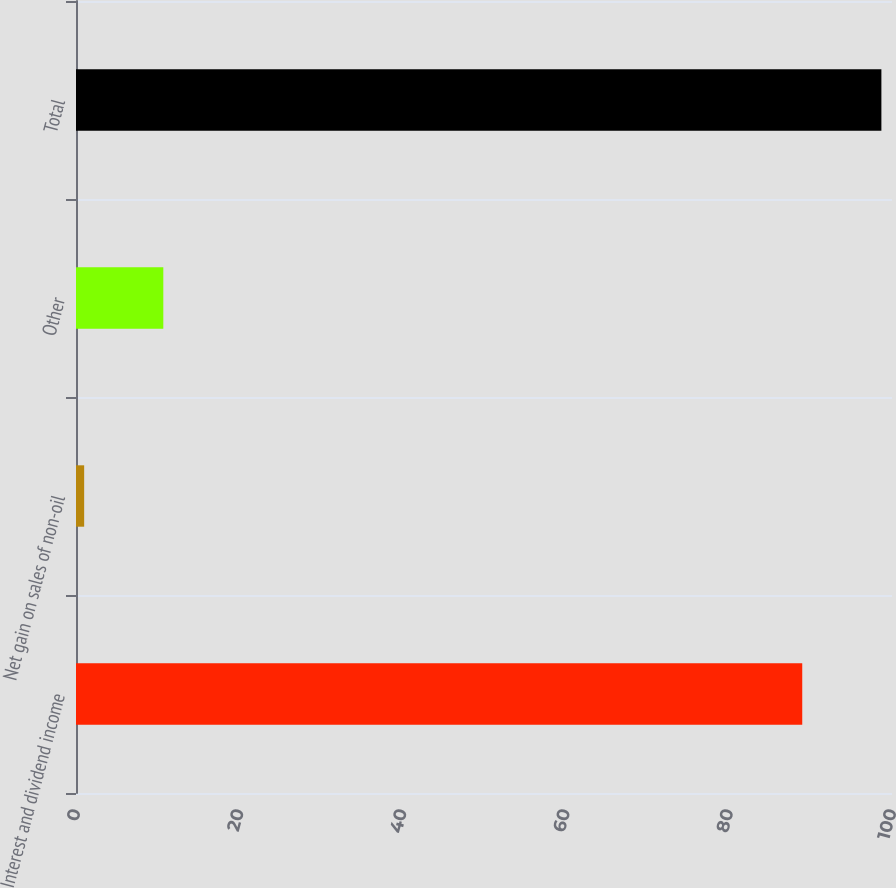<chart> <loc_0><loc_0><loc_500><loc_500><bar_chart><fcel>Interest and dividend income<fcel>Net gain on sales of non-oil<fcel>Other<fcel>Total<nl><fcel>89<fcel>1<fcel>10.7<fcel>98.7<nl></chart> 